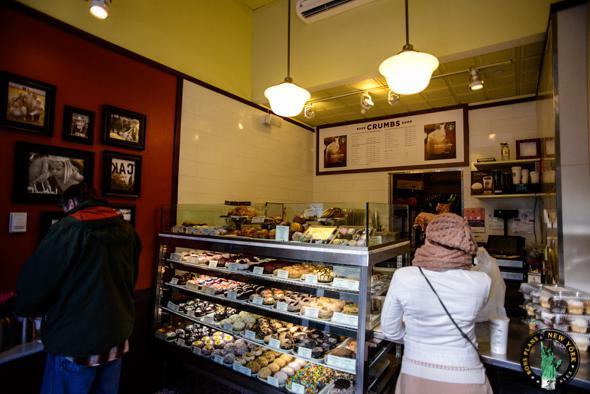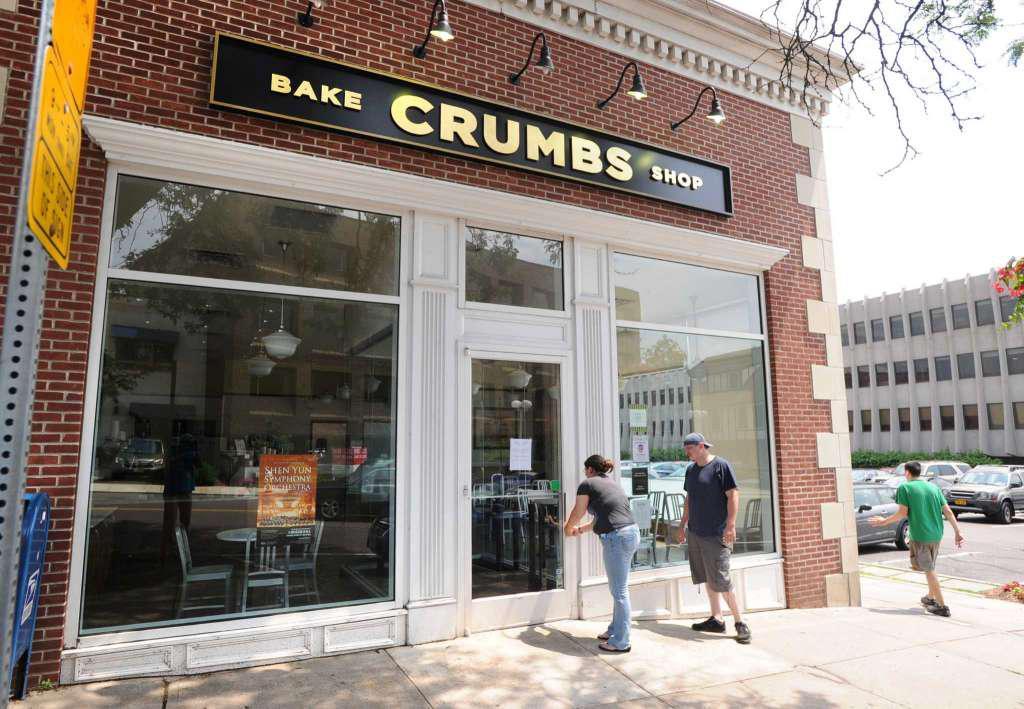The first image is the image on the left, the second image is the image on the right. Examine the images to the left and right. Is the description "An image shows at least one person on the sidewalk in front of the shop in the daytime." accurate? Answer yes or no. Yes. 